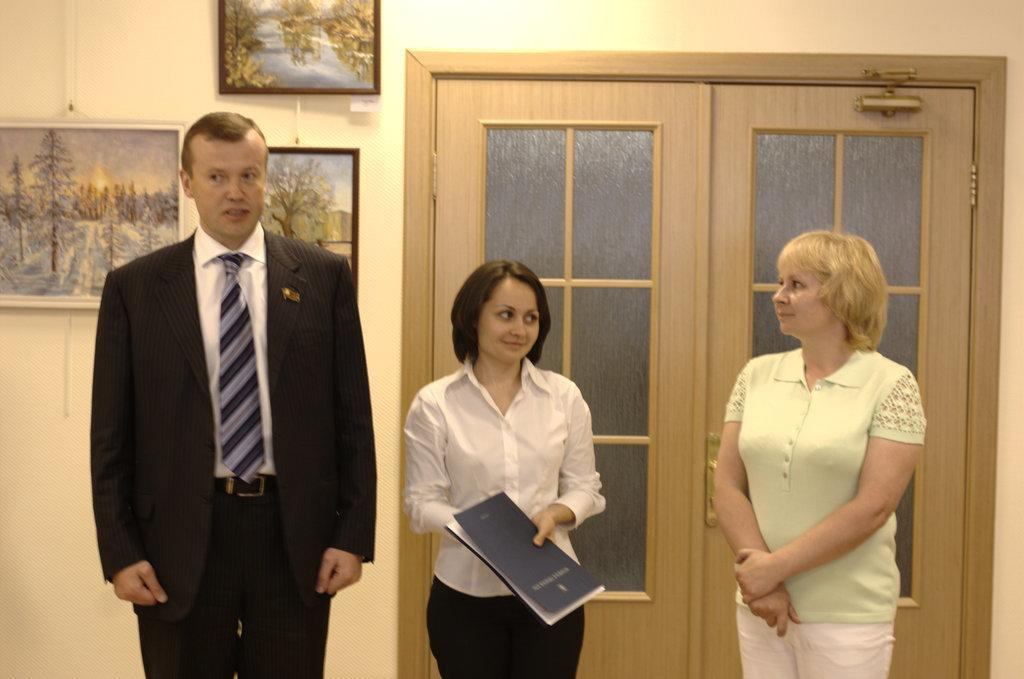How many people are standing on the path in the image? There are three people standing on the path in the image. What is the woman holding in her hand? The woman is holding a book in her hand. What can be seen on the wall in the image? There are frames visible on the wall. What is located in the background of the image? There is a door in the background. What type of milk is being poured into the frames on the wall? There is no milk present in the image, and the frames on the wall are not related to any pouring action. 